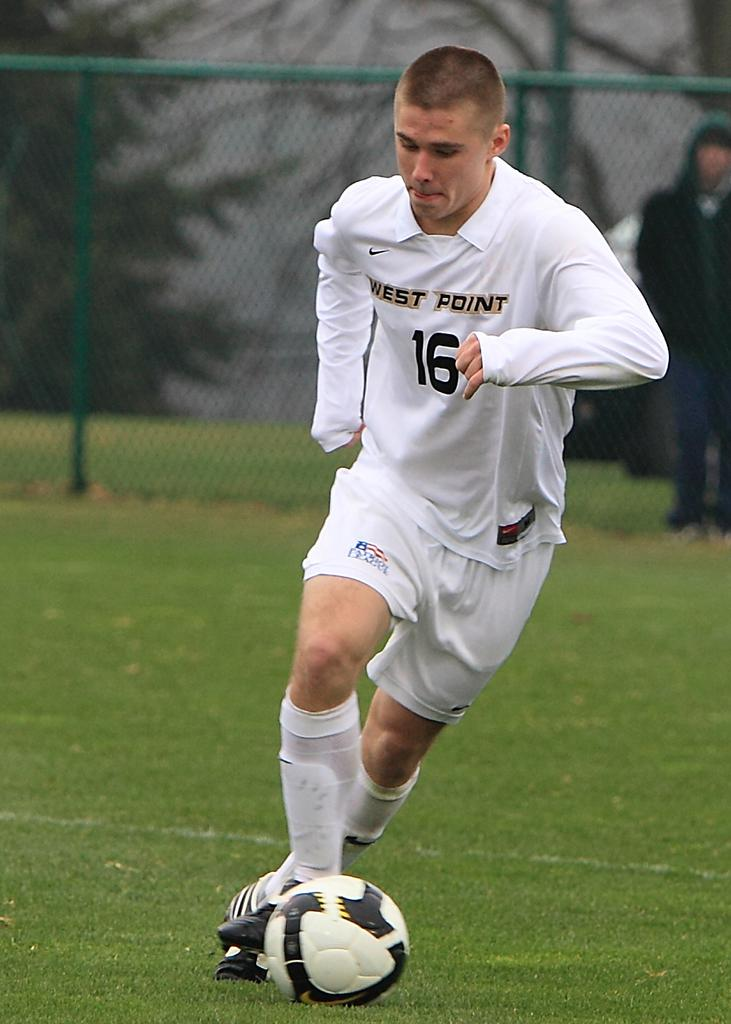What is the man in the image wearing? The man is wearing a white t-shirt, trousers, and shoes. What activity is the man engaged in? The man is playing a football game. Can you describe the background of the image? There are trees, grass, and a fence in the background of the image. Are there any other people visible in the image? Yes, there is a person in the background of the image. What type of bait is the man using to catch fish in the image? There is no mention of fishing or bait in the image; the man is playing a football game. What kind of apparatus is the man using to measure the height of the trees in the image? There is no apparatus for measuring tree heights visible in the image; the man is playing a football game. 